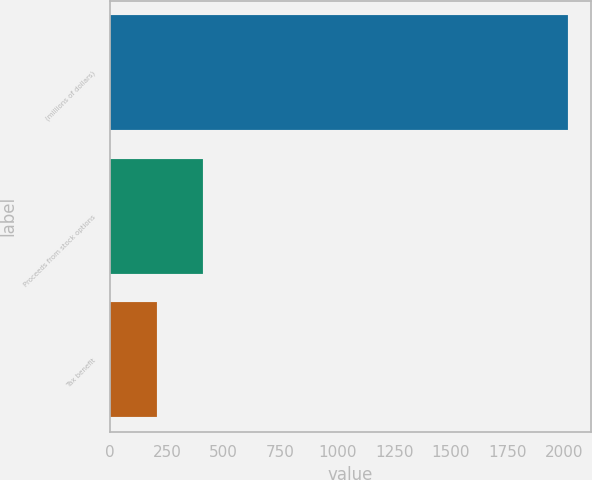Convert chart. <chart><loc_0><loc_0><loc_500><loc_500><bar_chart><fcel>(millions of dollars)<fcel>Proceeds from stock options<fcel>Tax benefit<nl><fcel>2015<fcel>408.2<fcel>207.35<nl></chart> 